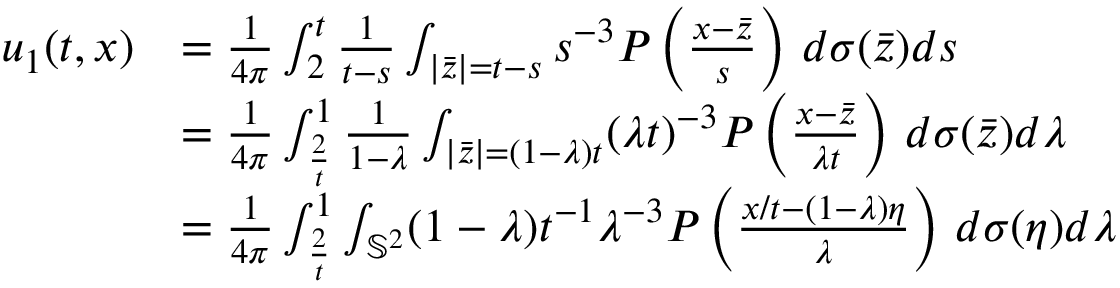Convert formula to latex. <formula><loc_0><loc_0><loc_500><loc_500>\begin{array} { r l } { u _ { 1 } ( t , x ) } & { = \frac { 1 } 4 \pi } \int _ { 2 } ^ { t } \frac { 1 } { t - s } \int _ { | \bar { z } | = t - s } s ^ { - 3 } P \left ( \frac { x - \bar { z } } { s } \right ) \, d \sigma ( \bar { z } ) d s } \\ & { = \frac { 1 } 4 \pi } \int _ { \frac { 2 } { t } } ^ { 1 } \frac { 1 } { 1 - \lambda } \int _ { | \bar { z } | = ( 1 - \lambda ) t } ( \lambda t ) ^ { - 3 } P \left ( \frac { x - \bar { z } } { \lambda t } \right ) \, d \sigma ( \bar { z } ) d \lambda } \\ & { = \frac { 1 } 4 \pi } \int _ { \frac { 2 } { t } } ^ { 1 } \int _ { \mathbb { S } ^ { 2 } } ( 1 - \lambda ) t ^ { - 1 } \lambda ^ { - 3 } P \left ( \frac { x / t - ( 1 - \lambda ) \eta } { \lambda } \right ) \, d \sigma ( \eta ) d \lambda } \end{array}</formula> 